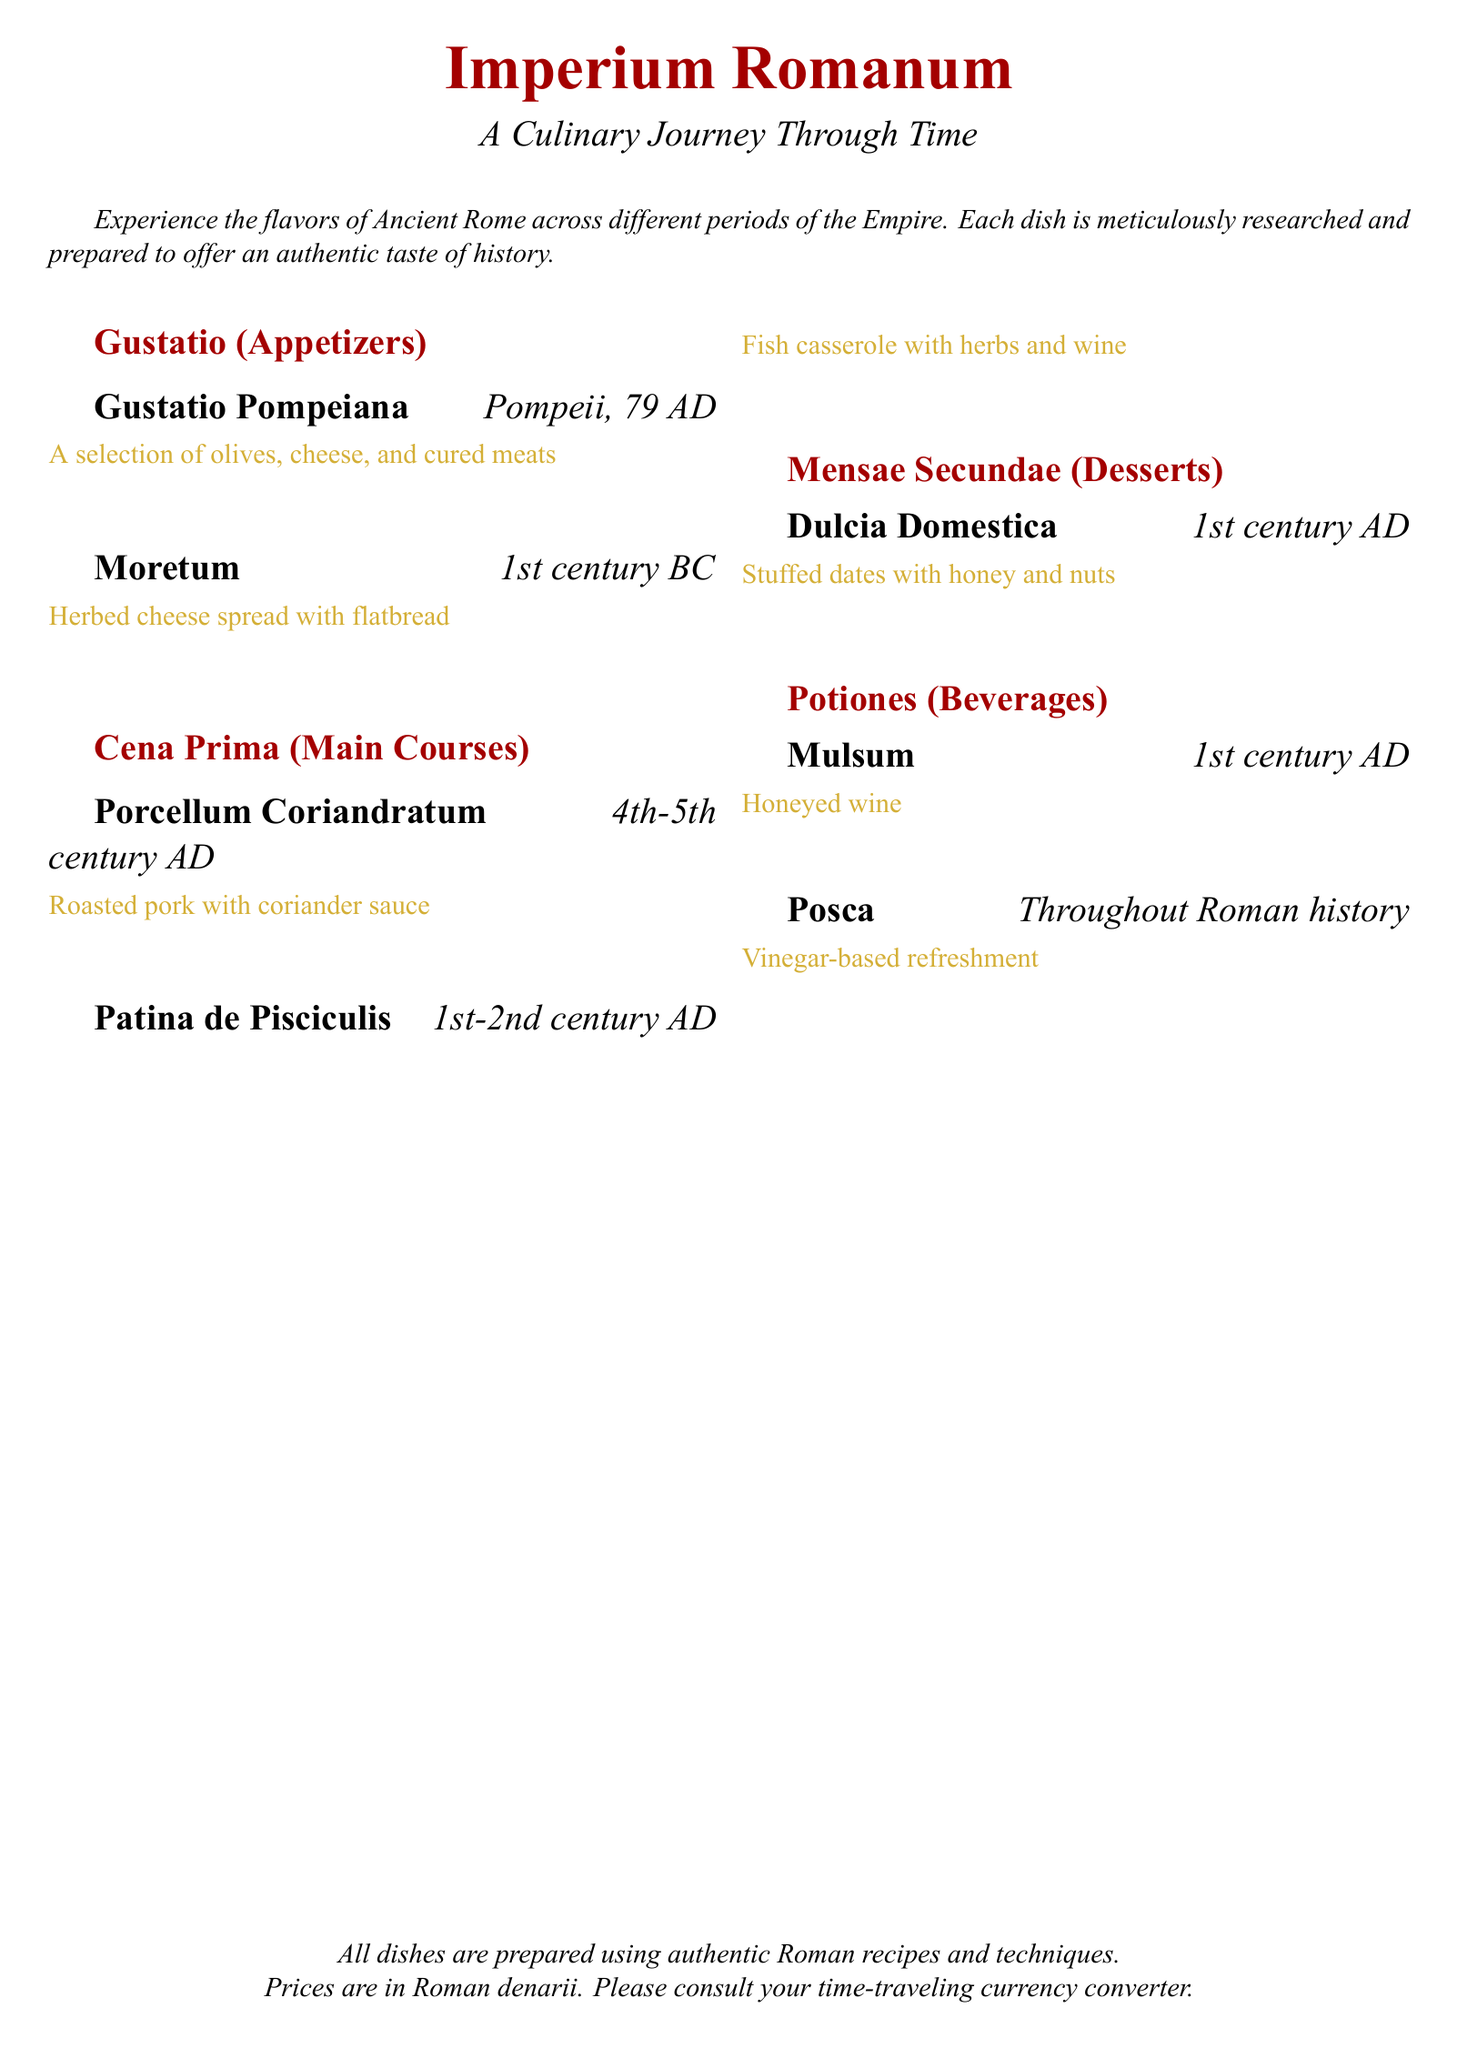What is the name of the dessert? The name of the dessert listed in the menu is "Dulcia Domestica".
Answer: Dulcia Domestica What century does "Moretum" belong to? "Moretum" is noted on the menu as originating from the 1st century BC.
Answer: 1st century BC Which dish is described as a fish casserole? The dish that is described as a fish casserole is "Patina de Pisciculis".
Answer: Patina de Pisciculis What type of beverage is "Mulsum"? "Mulsum" is categorized as a honeyed wine in the menu.
Answer: Honeyed wine Which course follows the "Gustatio"? "Cena Prima" follows the "Gustatio" as the next course in the menu.
Answer: Cena Prima What is the historical origin of "Porcellum Coriandratum"? The dish "Porcellum Coriandratum" originates from the 4th-5th century AD.
Answer: 4th-5th century AD What are the ingredients in "Moretum"? "Moretum" consists of herbed cheese spread with flatbread.
Answer: Herbed cheese spread with flatbread What is the historical significance of "Posca"? "Posca" is identified in the menu as a vinegar-based refreshment used throughout Roman history.
Answer: Vinegar-based refreshment 